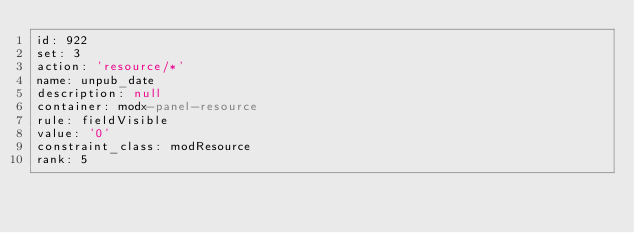Convert code to text. <code><loc_0><loc_0><loc_500><loc_500><_YAML_>id: 922
set: 3
action: 'resource/*'
name: unpub_date
description: null
container: modx-panel-resource
rule: fieldVisible
value: '0'
constraint_class: modResource
rank: 5
</code> 